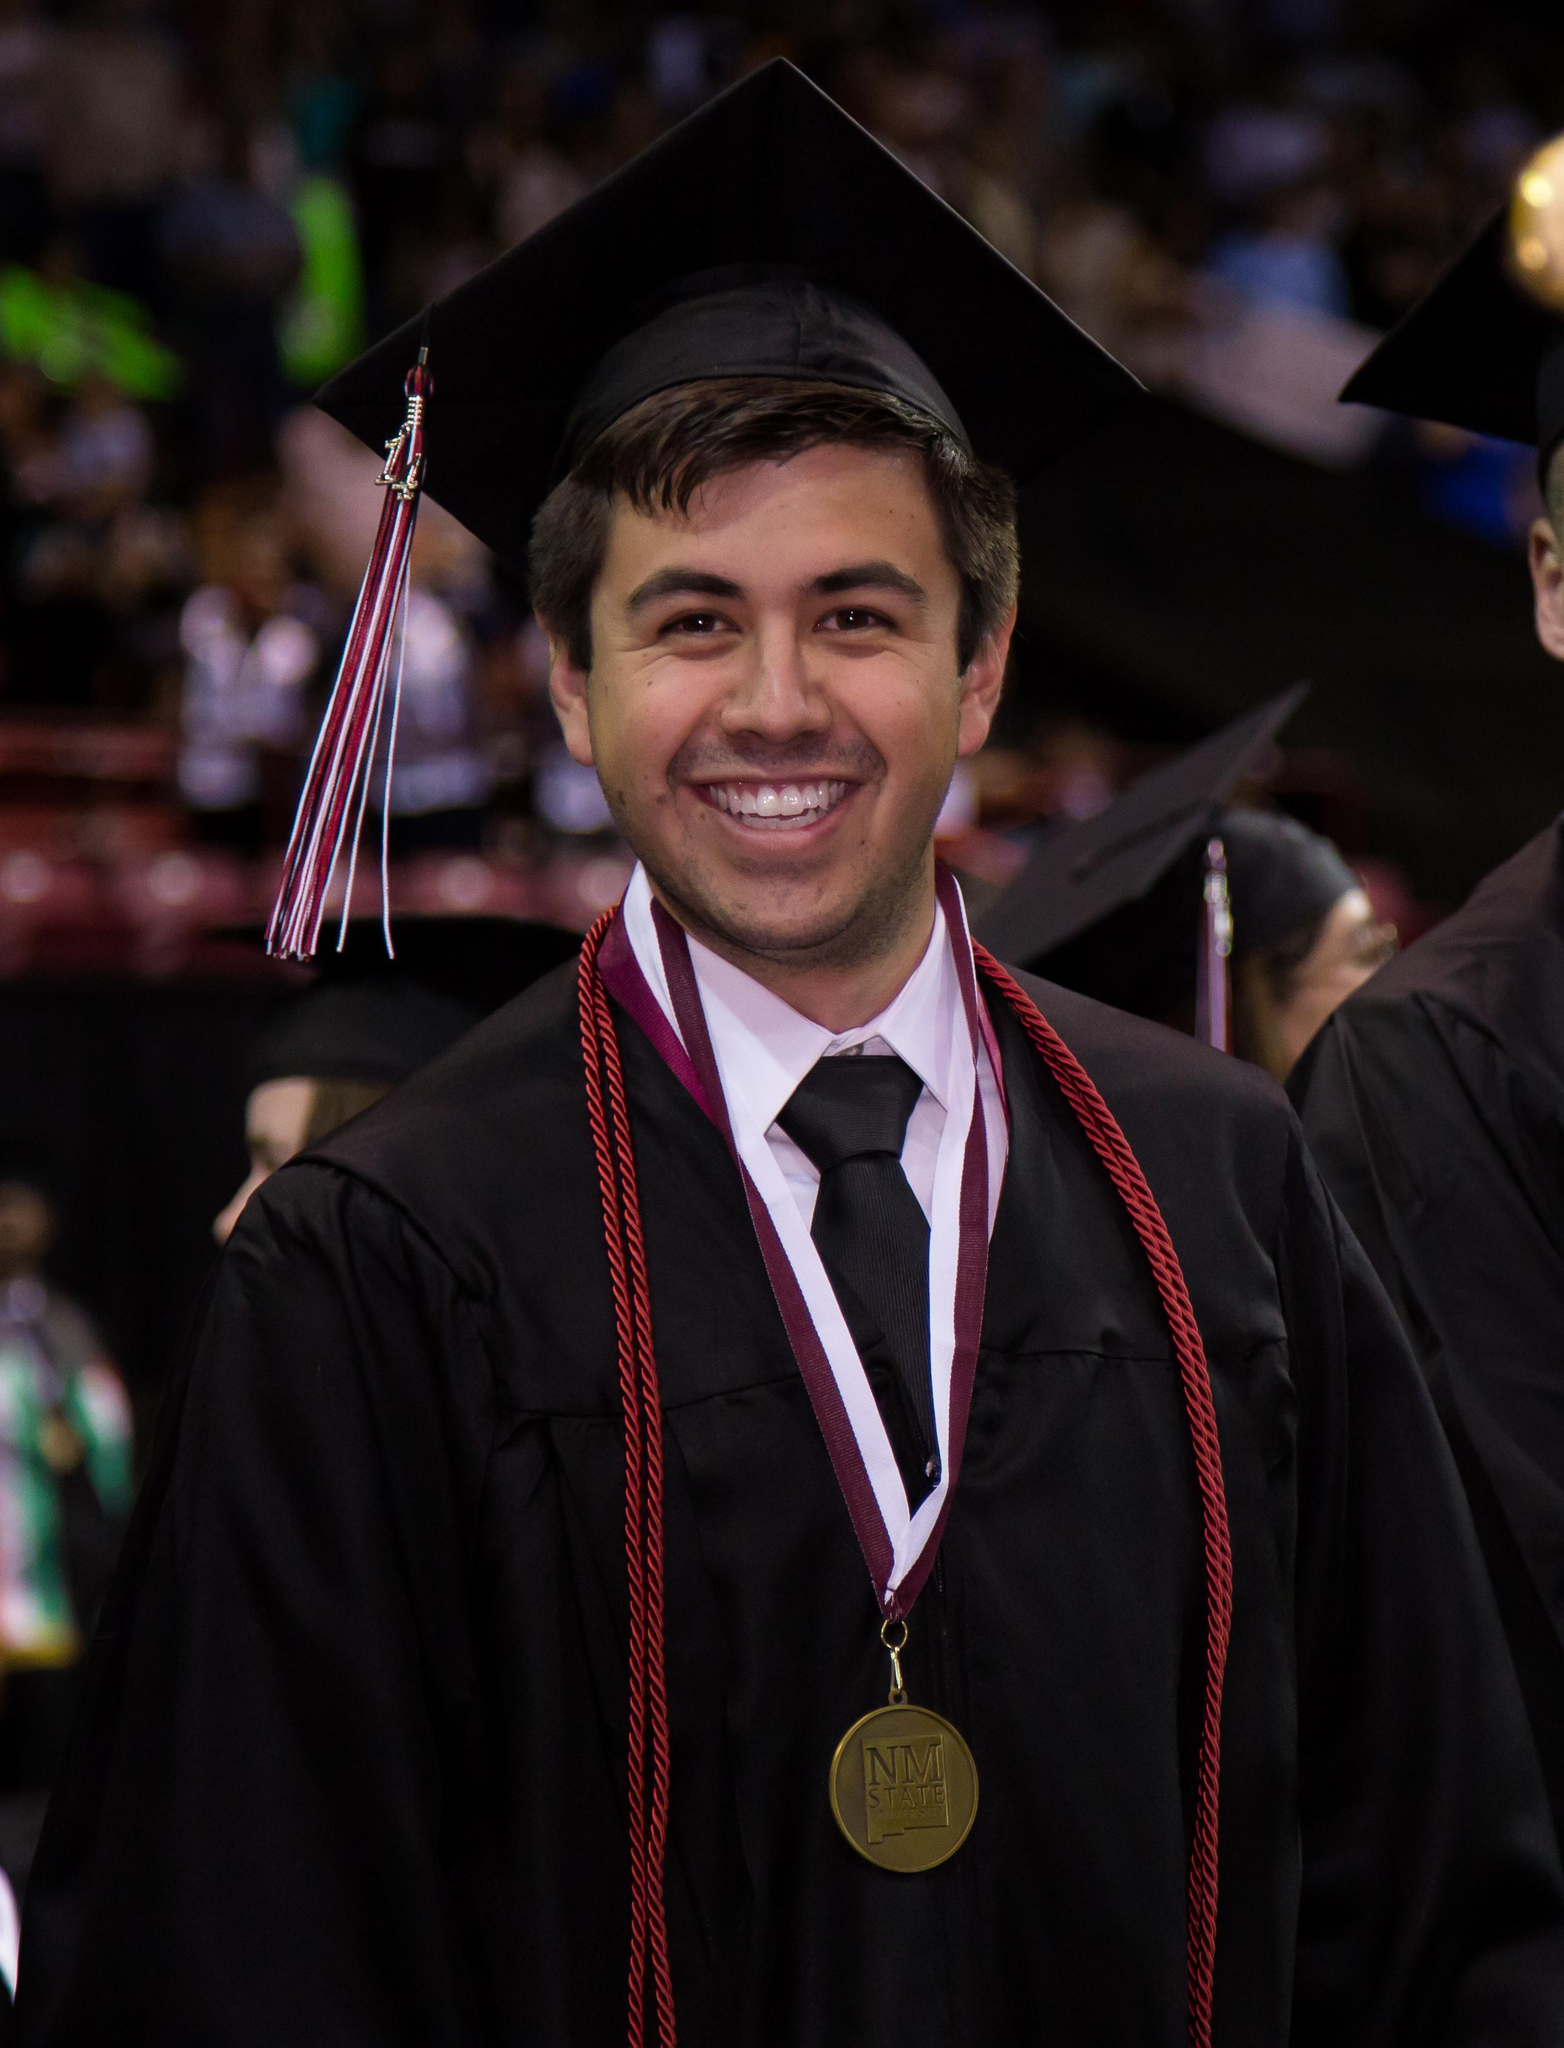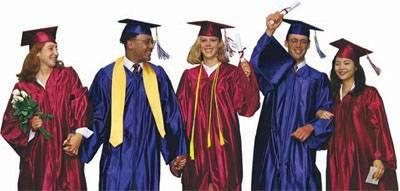The first image is the image on the left, the second image is the image on the right. Examine the images to the left and right. Is the description "There are at most two graduates in the left image." accurate? Answer yes or no. Yes. The first image is the image on the left, the second image is the image on the right. For the images shown, is this caption "Some of the people's tassels on their hats are yellow." true? Answer yes or no. No. 